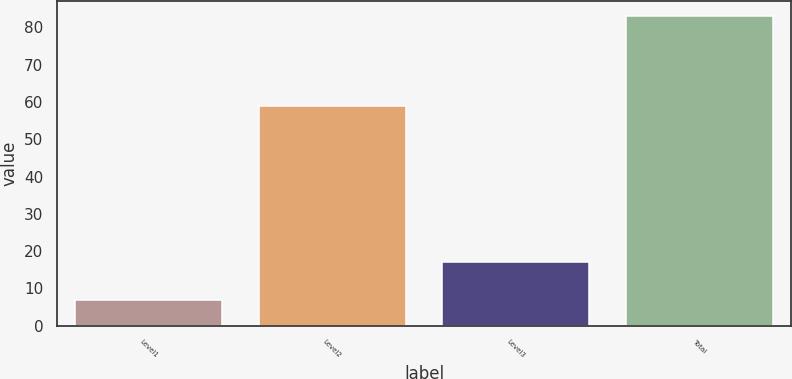Convert chart to OTSL. <chart><loc_0><loc_0><loc_500><loc_500><bar_chart><fcel>Level1<fcel>Level2<fcel>Level3<fcel>Total<nl><fcel>7<fcel>59<fcel>17<fcel>83<nl></chart> 